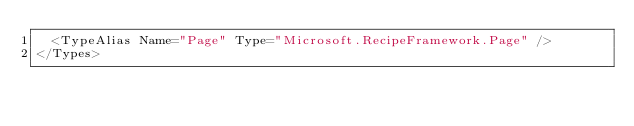<code> <loc_0><loc_0><loc_500><loc_500><_XML_>  <TypeAlias Name="Page" Type="Microsoft.RecipeFramework.Page" />
</Types></code> 